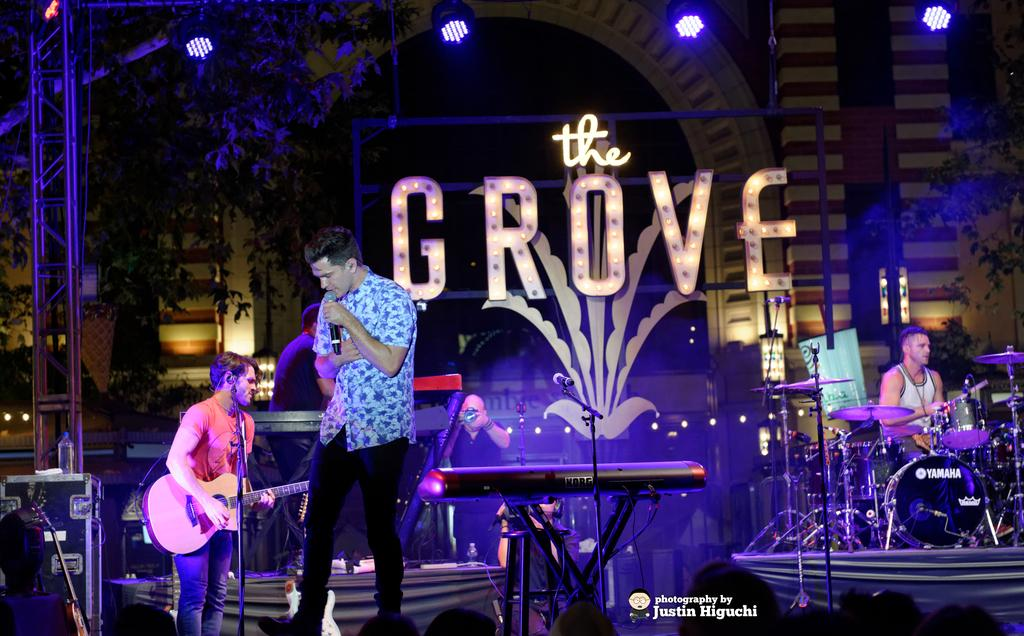What is the man on the stage doing? The man is singing into a microphone. What are the other people behind the man doing? The people behind the man are playing musical instruments. Can you describe the setting of the image? The setting is a stage, where the man is singing and the others are playing instruments. What type of cake is being served to the visitor in the image? There is no cake or visitor present in the image; it features a man singing on stage with other people playing musical instruments. 